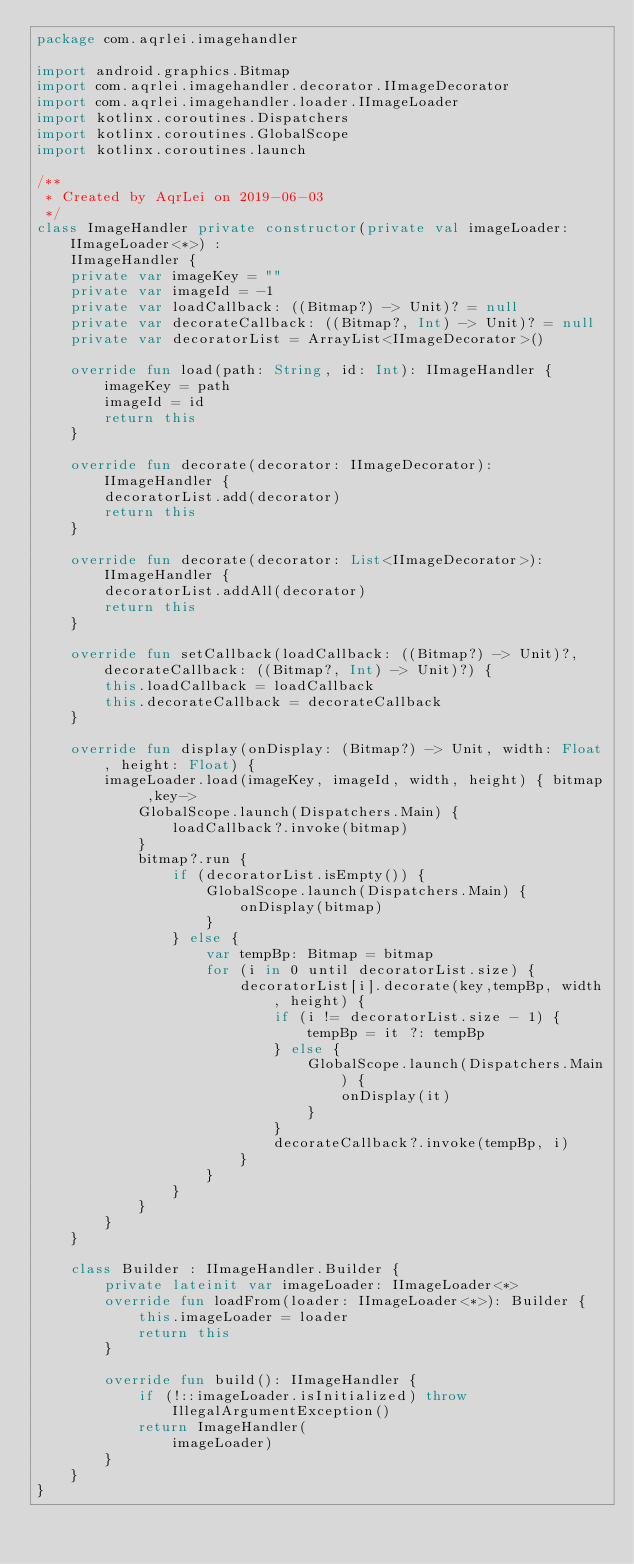<code> <loc_0><loc_0><loc_500><loc_500><_Kotlin_>package com.aqrlei.imagehandler

import android.graphics.Bitmap
import com.aqrlei.imagehandler.decorator.IImageDecorator
import com.aqrlei.imagehandler.loader.IImageLoader
import kotlinx.coroutines.Dispatchers
import kotlinx.coroutines.GlobalScope
import kotlinx.coroutines.launch

/**
 * Created by AqrLei on 2019-06-03
 */
class ImageHandler private constructor(private val imageLoader: IImageLoader<*>) :
    IImageHandler {
    private var imageKey = ""
    private var imageId = -1
    private var loadCallback: ((Bitmap?) -> Unit)? = null
    private var decorateCallback: ((Bitmap?, Int) -> Unit)? = null
    private var decoratorList = ArrayList<IImageDecorator>()

    override fun load(path: String, id: Int): IImageHandler {
        imageKey = path
        imageId = id
        return this
    }

    override fun decorate(decorator: IImageDecorator): IImageHandler {
        decoratorList.add(decorator)
        return this
    }

    override fun decorate(decorator: List<IImageDecorator>): IImageHandler {
        decoratorList.addAll(decorator)
        return this
    }

    override fun setCallback(loadCallback: ((Bitmap?) -> Unit)?, decorateCallback: ((Bitmap?, Int) -> Unit)?) {
        this.loadCallback = loadCallback
        this.decorateCallback = decorateCallback
    }

    override fun display(onDisplay: (Bitmap?) -> Unit, width: Float, height: Float) {
        imageLoader.load(imageKey, imageId, width, height) { bitmap ,key->
            GlobalScope.launch(Dispatchers.Main) {
                loadCallback?.invoke(bitmap)
            }
            bitmap?.run {
                if (decoratorList.isEmpty()) {
                    GlobalScope.launch(Dispatchers.Main) {
                        onDisplay(bitmap)
                    }
                } else {
                    var tempBp: Bitmap = bitmap
                    for (i in 0 until decoratorList.size) {
                        decoratorList[i].decorate(key,tempBp, width, height) {
                            if (i != decoratorList.size - 1) {
                                tempBp = it ?: tempBp
                            } else {
                                GlobalScope.launch(Dispatchers.Main) {
                                    onDisplay(it)
                                }
                            }
                            decorateCallback?.invoke(tempBp, i)
                        }
                    }
                }
            }
        }
    }

    class Builder : IImageHandler.Builder {
        private lateinit var imageLoader: IImageLoader<*>
        override fun loadFrom(loader: IImageLoader<*>): Builder {
            this.imageLoader = loader
            return this
        }

        override fun build(): IImageHandler {
            if (!::imageLoader.isInitialized) throw IllegalArgumentException()
            return ImageHandler(
                imageLoader)
        }
    }
}</code> 